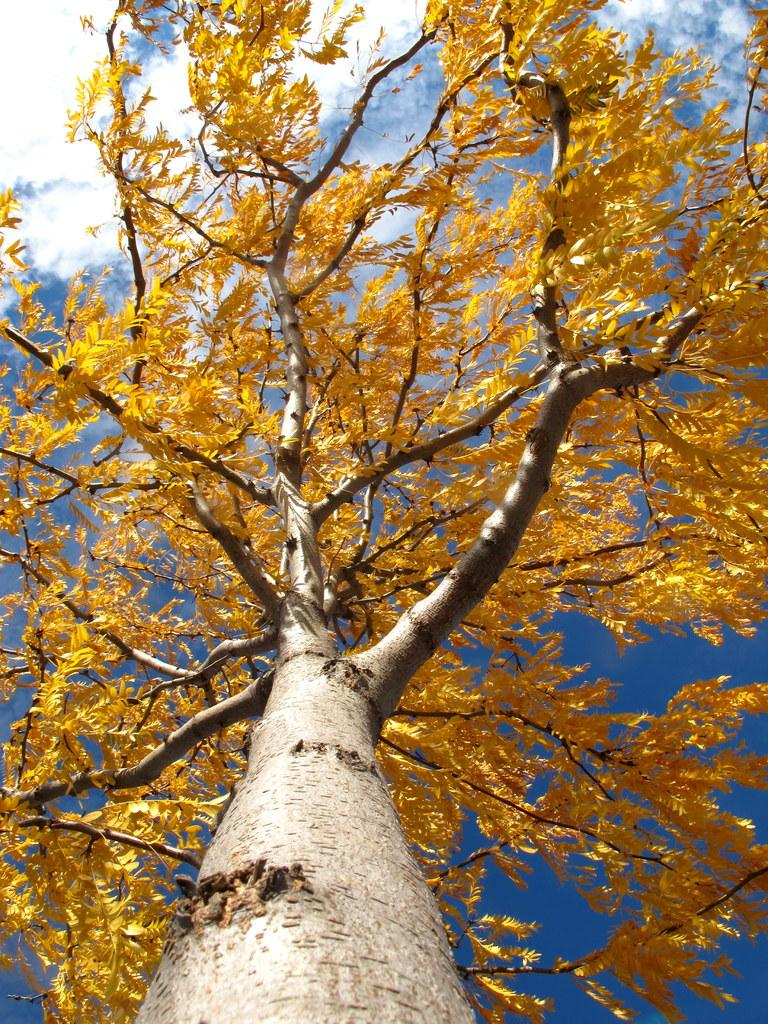What type of plant can be seen in the image? There is a tree in the image. What is visible in the background of the image? The sky is visible in the background of the image. What can be observed in the sky? Clouds are present in the sky. What type of snail can be seen climbing the tree in the image? There is no snail present in the image; it only features a tree and the sky with clouds. 